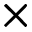<formula> <loc_0><loc_0><loc_500><loc_500>\times</formula> 